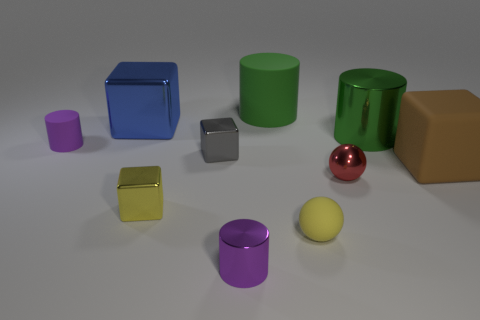What is the material of the yellow ball that is the same size as the gray metallic object?
Ensure brevity in your answer.  Rubber. There is a rubber thing in front of the large brown cube; what shape is it?
Ensure brevity in your answer.  Sphere. Is the purple thing that is behind the brown object made of the same material as the yellow thing in front of the small yellow cube?
Give a very brief answer. Yes. What number of cyan rubber things are the same shape as the big blue thing?
Your answer should be very brief. 0. What material is the other tiny cylinder that is the same color as the small metallic cylinder?
Provide a succinct answer. Rubber. What number of objects are rubber things or spheres right of the yellow rubber thing?
Ensure brevity in your answer.  5. What is the material of the brown thing?
Give a very brief answer. Rubber. What is the material of the other tiny thing that is the same shape as the yellow metallic thing?
Ensure brevity in your answer.  Metal. There is a large cube on the right side of the big green object right of the red shiny thing; what color is it?
Offer a very short reply. Brown. What number of metal objects are either large brown blocks or yellow blocks?
Offer a terse response. 1. 